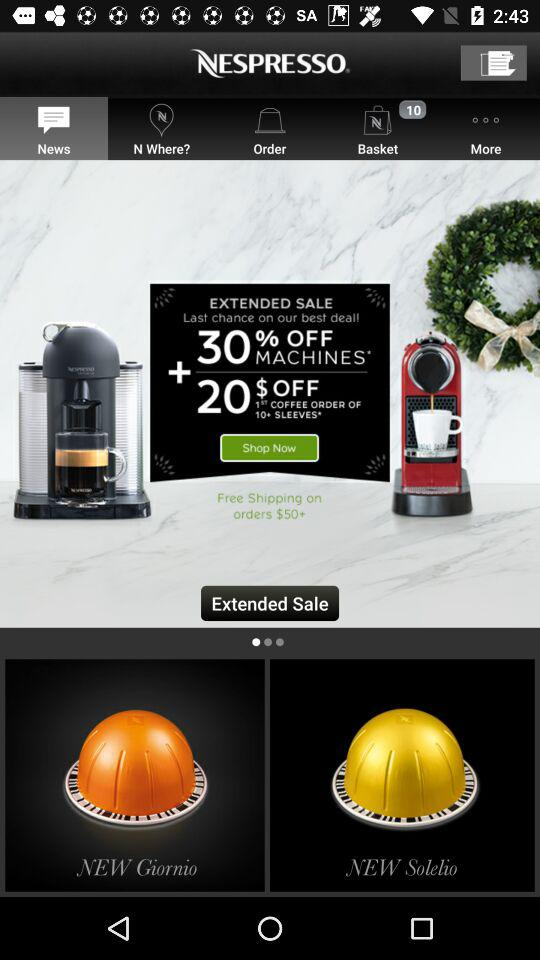Above what order price is free shipping available? Free shipping is available on orders of $50+. 